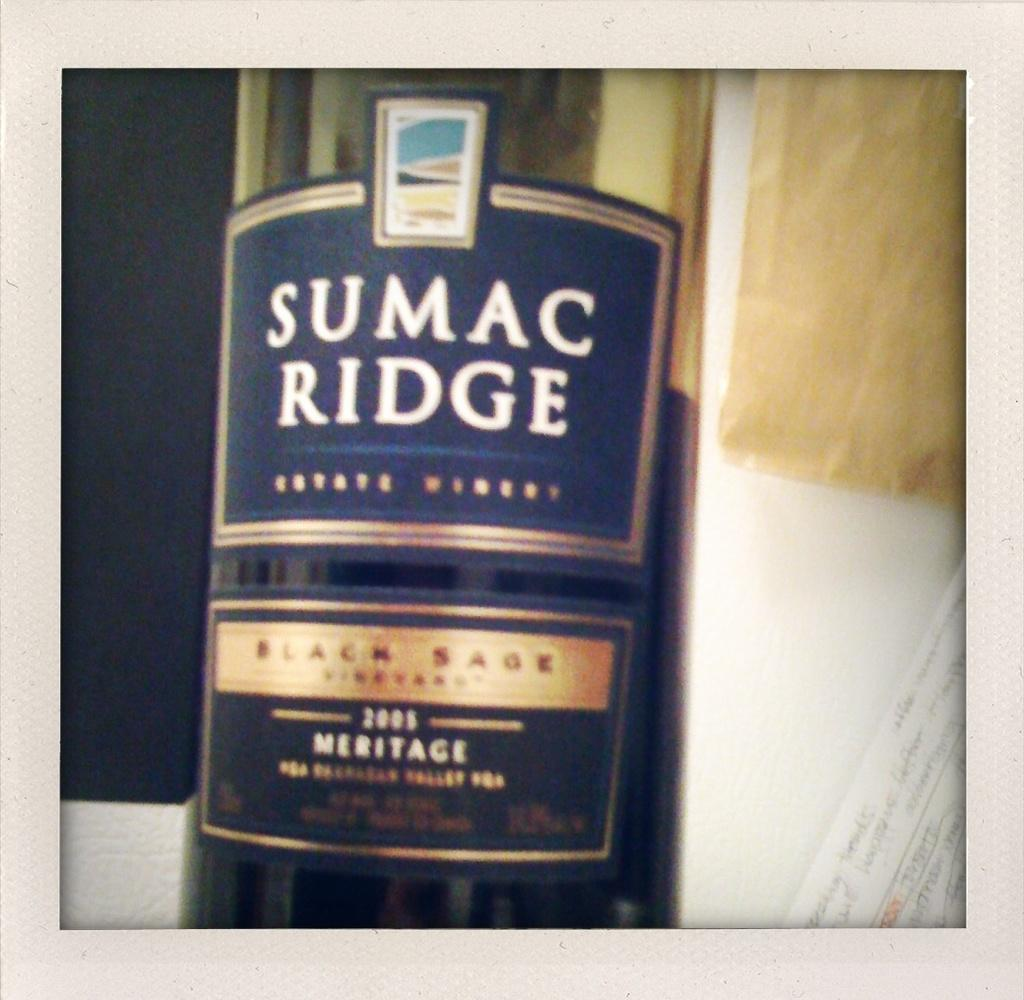<image>
Describe the image concisely. Bottle with a label that says SUMAC RIDGE on it. 